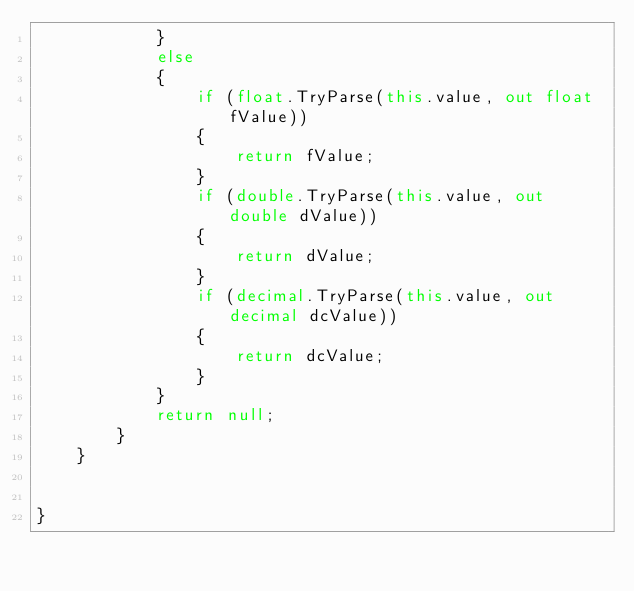Convert code to text. <code><loc_0><loc_0><loc_500><loc_500><_C#_>            }
            else
            {
                if (float.TryParse(this.value, out float fValue))
                {
                    return fValue;
                }
                if (double.TryParse(this.value, out double dValue))
                {
                    return dValue;
                }
                if (decimal.TryParse(this.value, out decimal dcValue))
                {
                    return dcValue;
                }
            }
            return null;
        }
    }


}</code> 